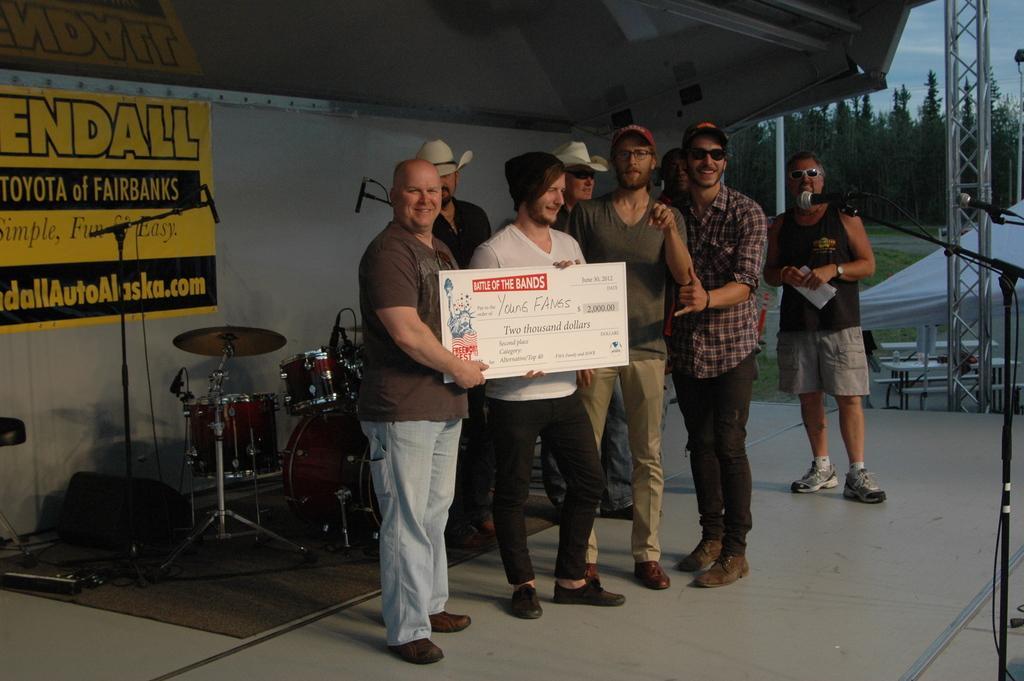Could you give a brief overview of what you see in this image? In this image we can see persons standing on the floor and one of them is holding a cheque in the hands. In the background we can see musical instruments, advertisement pasted on the wall, mics, mic stands and carpet. 